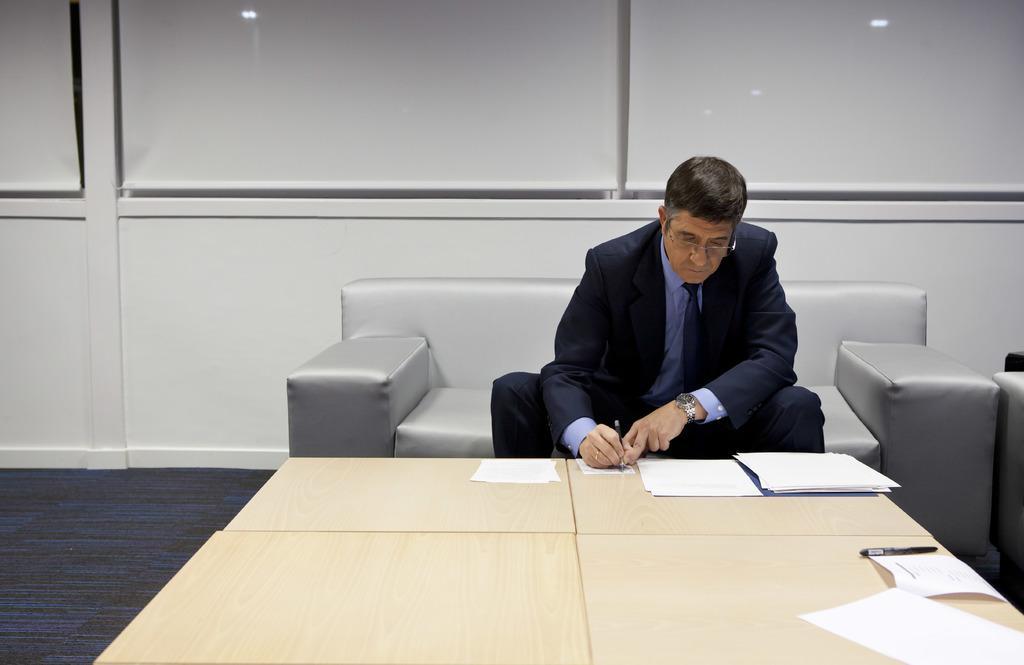In one or two sentences, can you explain what this image depicts? In the image there was a person sitting on the couch,he was writing something on the paper the paper was on the table. 